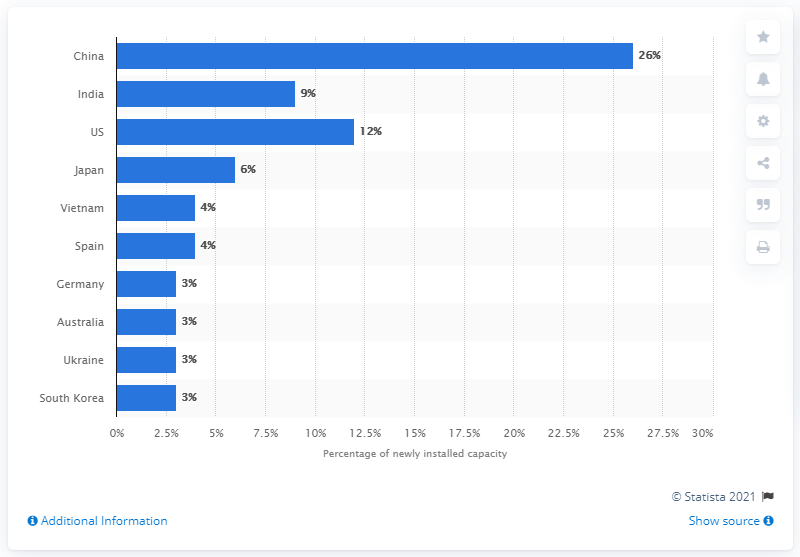Specify some key components in this picture. In 2019, the United States and India together accounted for approximately one-fifth of the world's new solar capacity installation. 